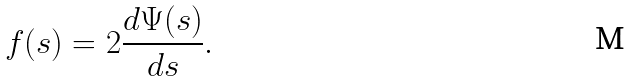Convert formula to latex. <formula><loc_0><loc_0><loc_500><loc_500>f ( s ) = 2 \frac { d \Psi ( s ) } { d s } .</formula> 